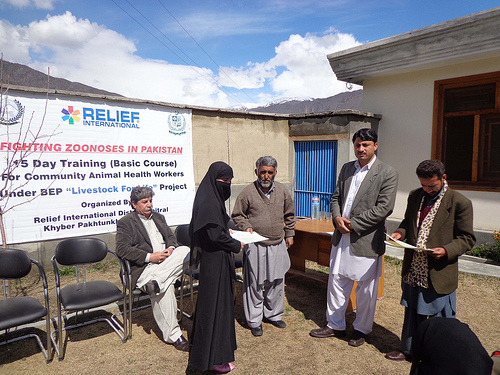<image>
Is there a woman in front of the sign? Yes. The woman is positioned in front of the sign, appearing closer to the camera viewpoint. 